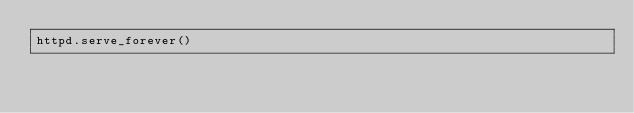Convert code to text. <code><loc_0><loc_0><loc_500><loc_500><_Python_>httpd.serve_forever()
</code> 